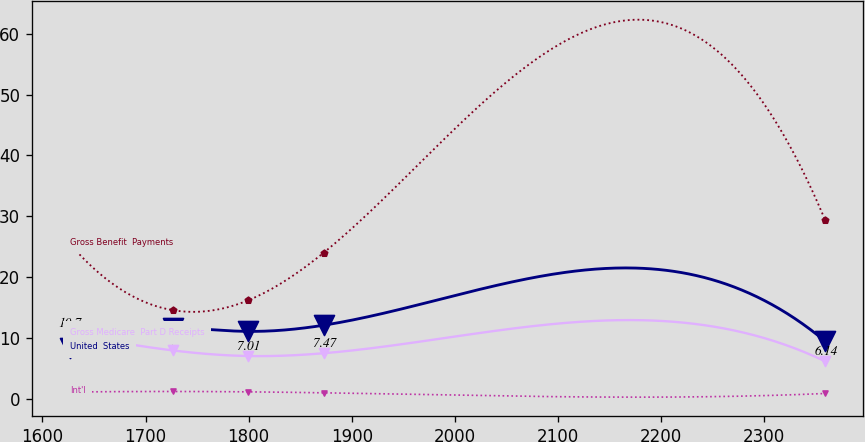Convert chart. <chart><loc_0><loc_0><loc_500><loc_500><line_chart><ecel><fcel>Gross Medicare  Part D Receipts<fcel>Gross Benefit  Payments<fcel>United  States<fcel>Int'l<nl><fcel>1626.5<fcel>10.7<fcel>25.5<fcel>8.37<fcel>1.09<nl><fcel>1726.42<fcel>7.93<fcel>14.55<fcel>11.69<fcel>1.18<nl><fcel>1799.67<fcel>7.01<fcel>16.18<fcel>11.06<fcel>1.12<nl><fcel>1872.92<fcel>7.47<fcel>24.02<fcel>12.08<fcel>0.96<nl><fcel>2359<fcel>6.14<fcel>29.33<fcel>9.44<fcel>0.85<nl></chart> 